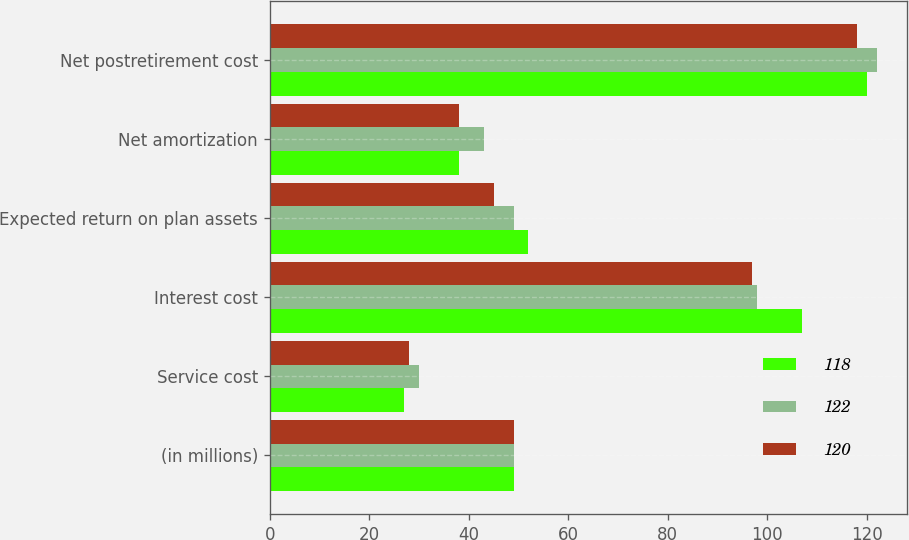Convert chart. <chart><loc_0><loc_0><loc_500><loc_500><stacked_bar_chart><ecel><fcel>(in millions)<fcel>Service cost<fcel>Interest cost<fcel>Expected return on plan assets<fcel>Net amortization<fcel>Net postretirement cost<nl><fcel>118<fcel>49<fcel>27<fcel>107<fcel>52<fcel>38<fcel>120<nl><fcel>122<fcel>49<fcel>30<fcel>98<fcel>49<fcel>43<fcel>122<nl><fcel>120<fcel>49<fcel>28<fcel>97<fcel>45<fcel>38<fcel>118<nl></chart> 